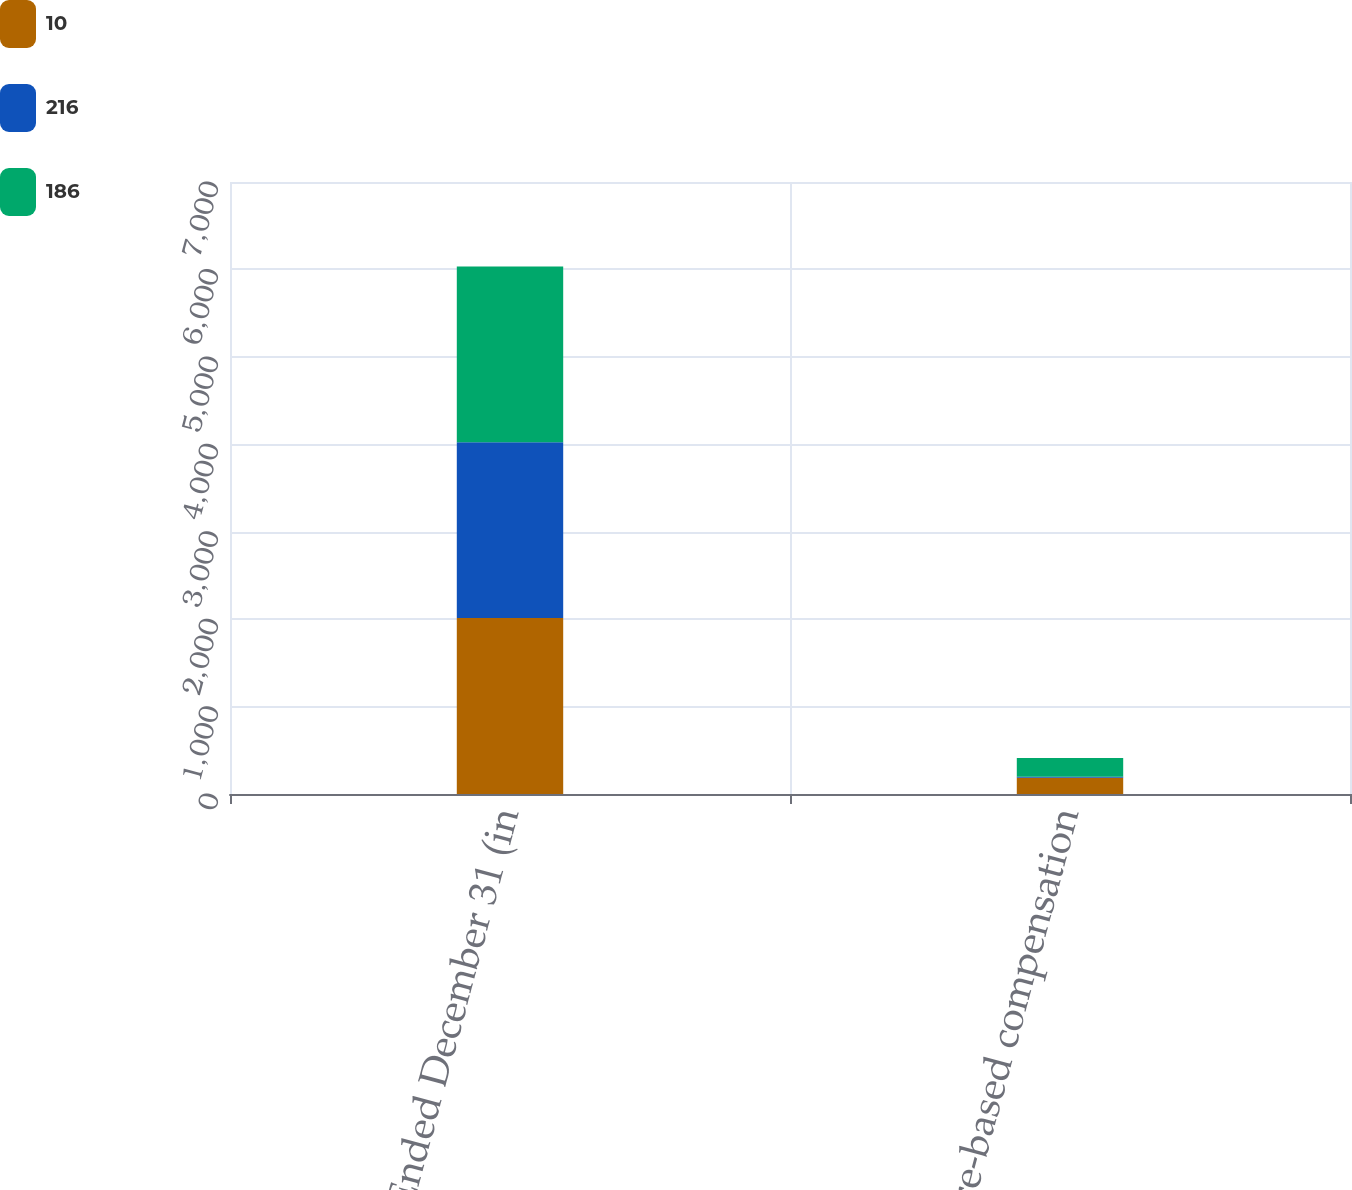Convert chart. <chart><loc_0><loc_0><loc_500><loc_500><stacked_bar_chart><ecel><fcel>Years Ended December 31 (in<fcel>Share-based compensation<nl><fcel>10<fcel>2012<fcel>186<nl><fcel>216<fcel>2011<fcel>10<nl><fcel>186<fcel>2010<fcel>216<nl></chart> 